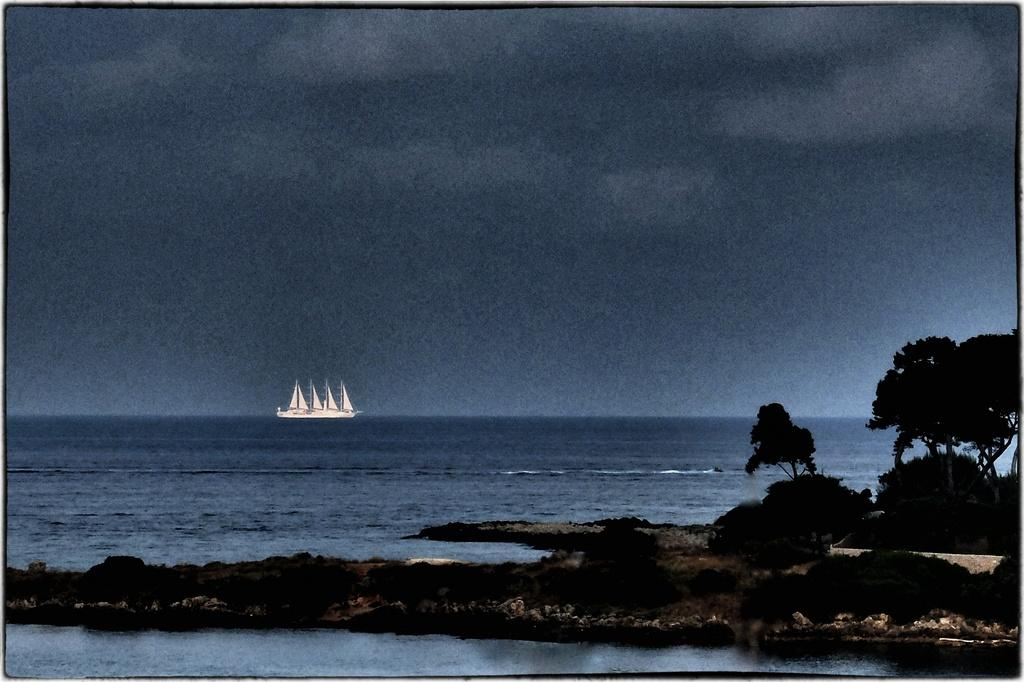What is one of the natural elements visible in the image? Water is visible in the image. What type of vegetation can be seen in the image? Trees are visible in the image. What man-made object can be seen in the distance? A ship is visible in the distance. What part of the natural environment is visible in the image? The sky is visible in the image. What type of net is being used to catch the fish in the image? There is no net or fish present in the image; it features water, trees, a ship, and the sky. 